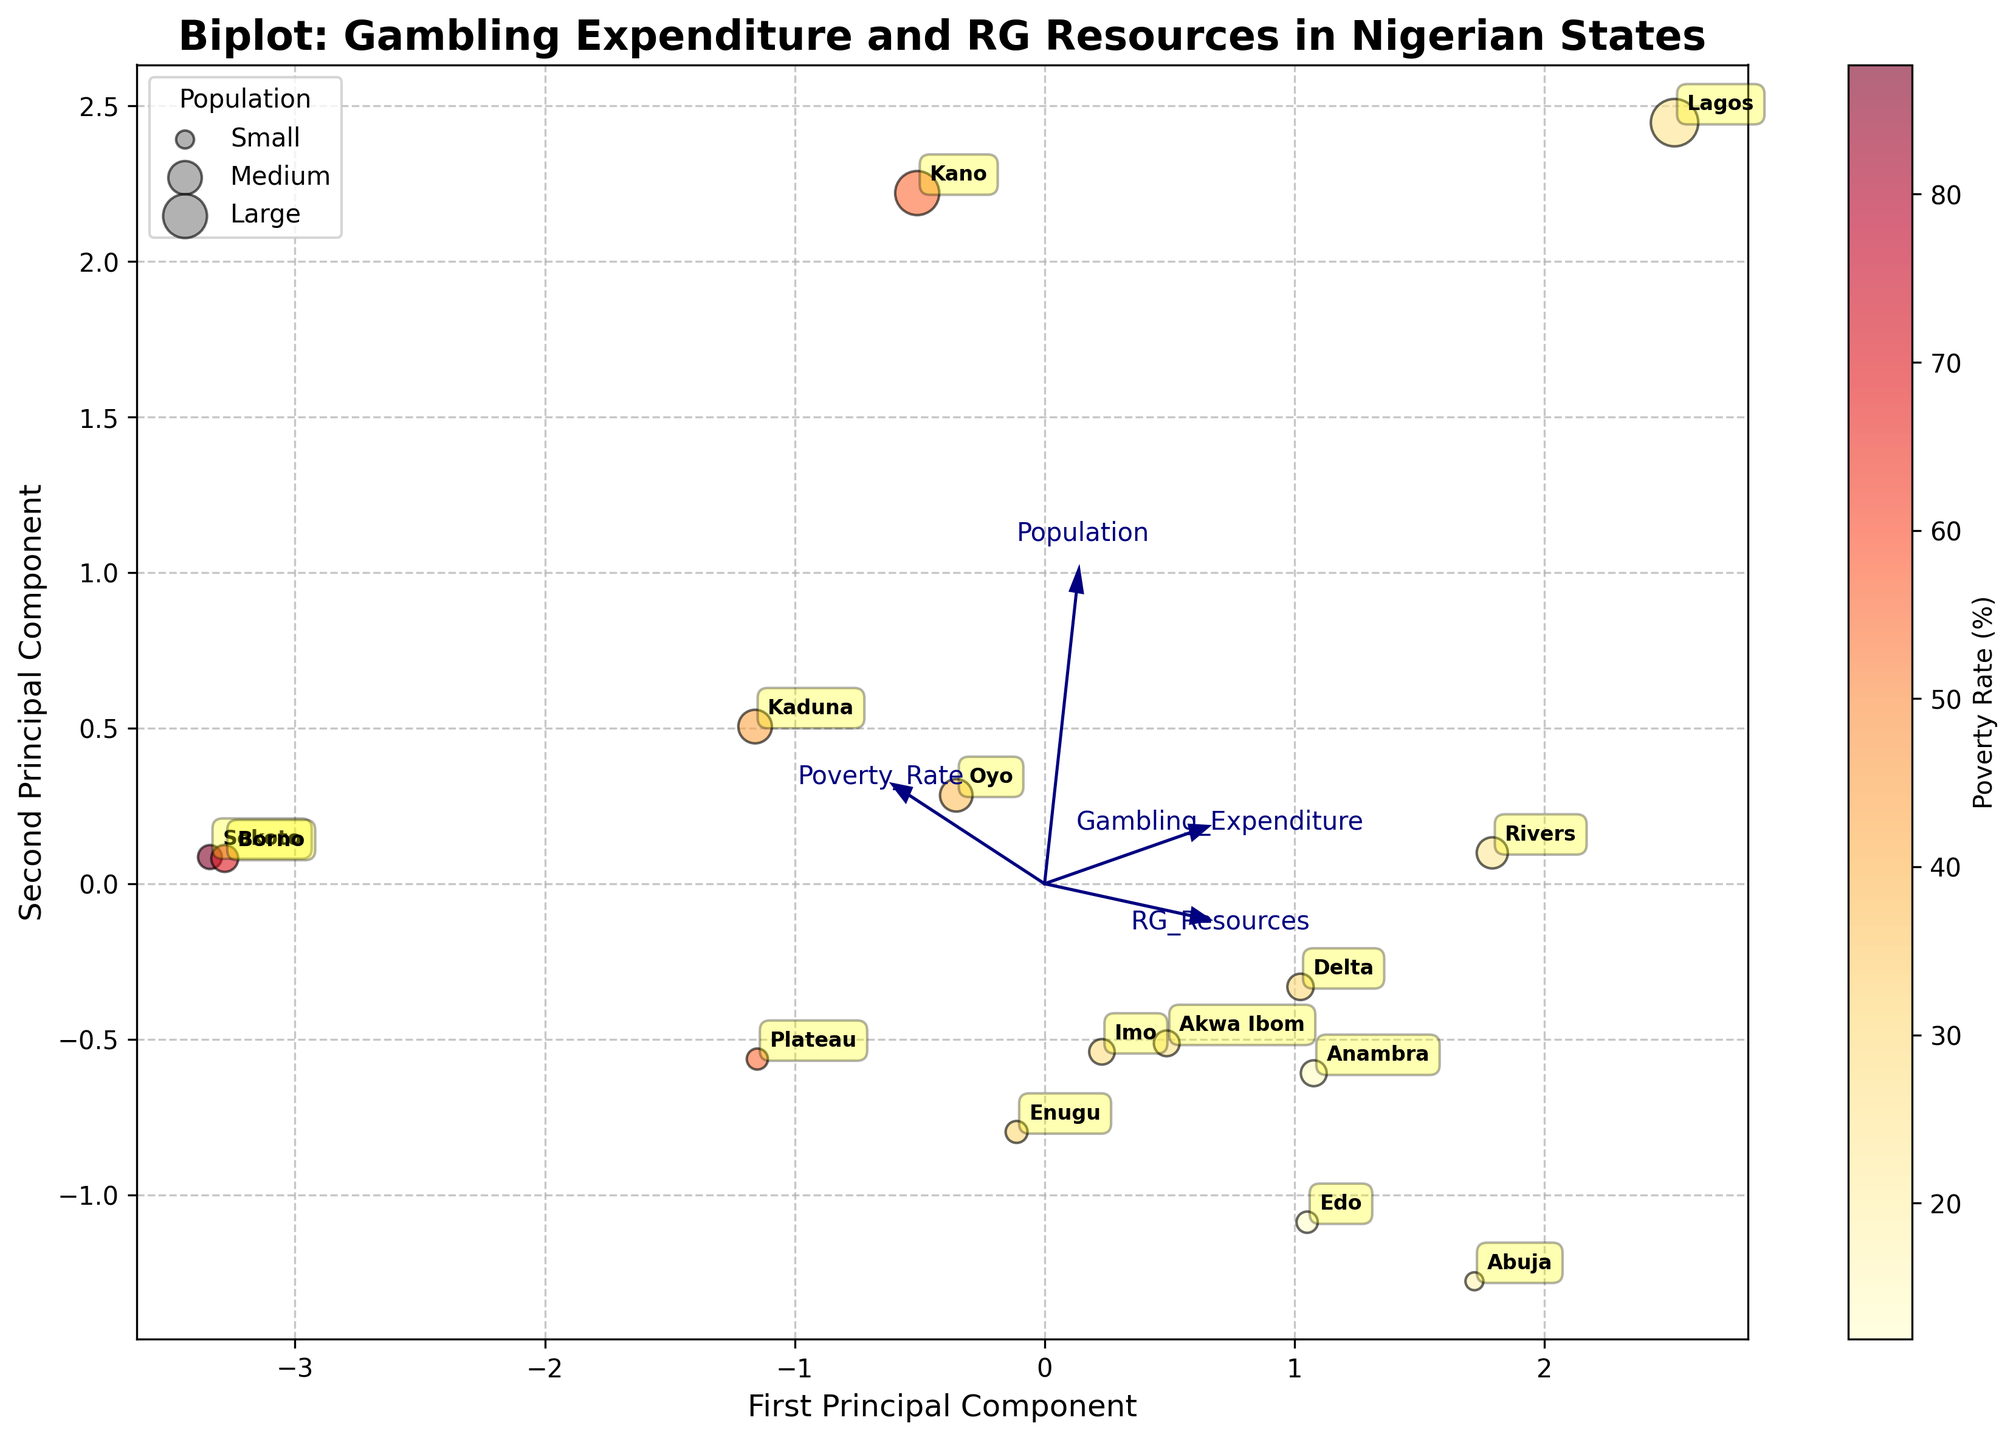What is the title of the biplot? The title of the biplot is typically found at the top of the figure. In this case, it reads "Biplot: Gambling Expenditure and RG Resources in Nigerian States".
Answer: Biplot: Gambling Expenditure and RG Resources in Nigerian States Which state has the highest poverty rate? To determine the state with the highest poverty rate, look at the colors of the data points. The darker or more intense the orange/red color, the higher the poverty rate. Identify the point with the most intense color.
Answer: Sokoto Which axis represents the first principal component? Axes in a biplot are usually labeled at the bottom (X-axis) and the side (Y-axis). The first principal component is typically labeled on the X-axis.
Answer: X-axis How many features are shown as vectors in the biplot? To count the number of features, identify how many vectors are drawn from the origin (0,0).
Answer: Four Which states are located in the positive half of both principal components (top-right quadrant)? Identify which states' labeled data points are in the top-right quadrant of the biplot, meaning both principal components are positive.
Answer: Rivers, Lagos, Anambra Which feature has the most significant positive correlation with the first principal component? Look for the vector that is most aligned with the direction of the first principal component (X-axis). The feature in this direction has the highest positive correlation with the first principal component.
Answer: Gambling_Expenditure Are there any states that have high gambling expenditure but low access to responsible gambling resources? Locate the data points placed high along the vector for Gambling_Expenditure but not similarly high along the vector for RG_Resources.
Answer: Kano, Oyo By how much does the first principal component account for more variance than the second principal component? This information is often found in the explanation or the axes labels (if it states percentages), but in this context, referencing explanations might be needed.
Answer: Not directly shown in the plot Which state has the smallest population size represented in the plot? Identify the data point with the smallest size, indicating the smallest population, and check its label.
Answer: Abuja What is the general trend shown between RG_Resources and Gambling_Expenditure? From the directions of the vectors for RG_Resources and Gambling_Expenditure, we can deduce if both vector directions are similar.
Answer: Positive correlation 